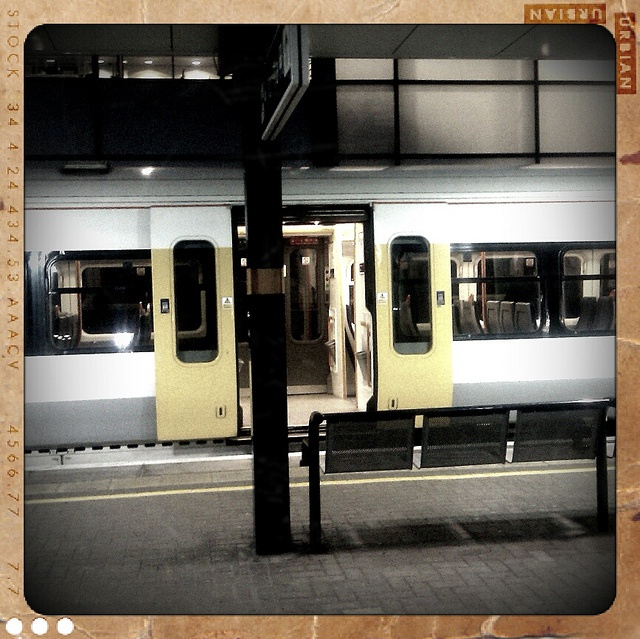Describe the objects in this image and their specific colors. I can see train in tan, black, white, darkgray, and gray tones and bench in tan, black, gray, darkgray, and lightgray tones in this image. 